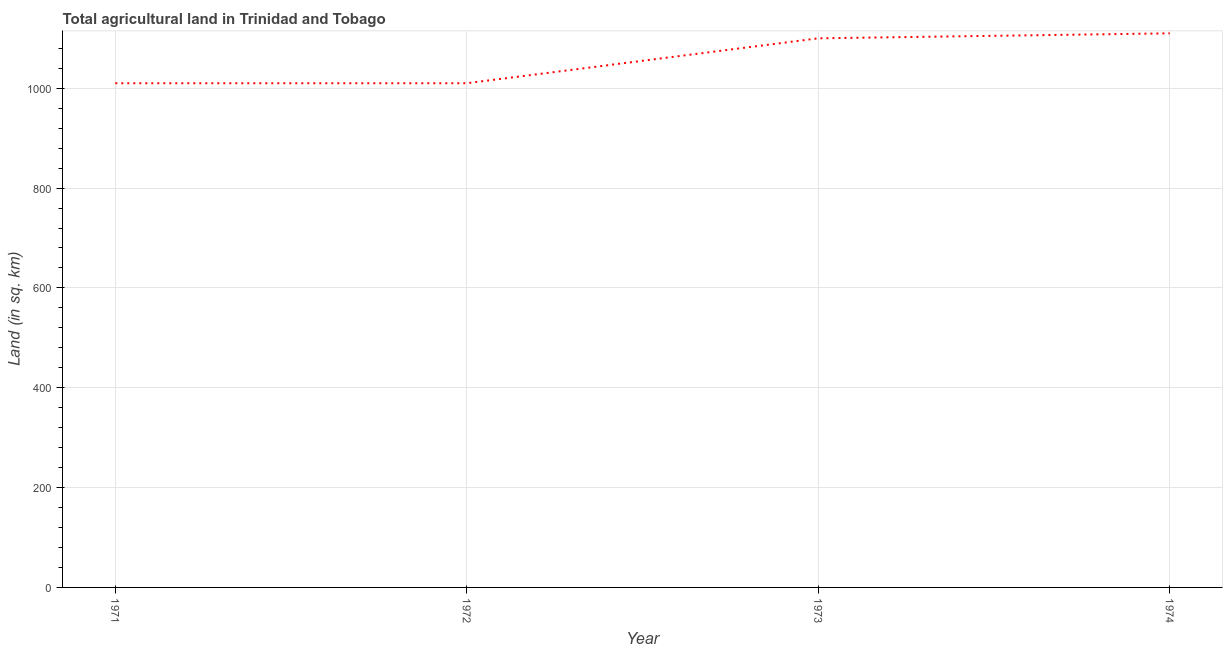What is the agricultural land in 1974?
Your answer should be very brief. 1110. Across all years, what is the maximum agricultural land?
Provide a succinct answer. 1110. Across all years, what is the minimum agricultural land?
Keep it short and to the point. 1010. In which year was the agricultural land maximum?
Offer a terse response. 1974. In which year was the agricultural land minimum?
Your answer should be compact. 1971. What is the sum of the agricultural land?
Make the answer very short. 4230. What is the difference between the agricultural land in 1972 and 1973?
Make the answer very short. -90. What is the average agricultural land per year?
Ensure brevity in your answer.  1057.5. What is the median agricultural land?
Make the answer very short. 1055. In how many years, is the agricultural land greater than 80 sq. km?
Make the answer very short. 4. What is the ratio of the agricultural land in 1972 to that in 1973?
Your answer should be very brief. 0.92. Is the difference between the agricultural land in 1971 and 1972 greater than the difference between any two years?
Ensure brevity in your answer.  No. What is the difference between the highest and the second highest agricultural land?
Provide a succinct answer. 10. Is the sum of the agricultural land in 1971 and 1972 greater than the maximum agricultural land across all years?
Make the answer very short. Yes. What is the difference between the highest and the lowest agricultural land?
Give a very brief answer. 100. In how many years, is the agricultural land greater than the average agricultural land taken over all years?
Make the answer very short. 2. Does the agricultural land monotonically increase over the years?
Ensure brevity in your answer.  No. How many years are there in the graph?
Provide a succinct answer. 4. Are the values on the major ticks of Y-axis written in scientific E-notation?
Offer a very short reply. No. What is the title of the graph?
Offer a very short reply. Total agricultural land in Trinidad and Tobago. What is the label or title of the Y-axis?
Offer a very short reply. Land (in sq. km). What is the Land (in sq. km) of 1971?
Provide a succinct answer. 1010. What is the Land (in sq. km) in 1972?
Keep it short and to the point. 1010. What is the Land (in sq. km) in 1973?
Offer a terse response. 1100. What is the Land (in sq. km) in 1974?
Keep it short and to the point. 1110. What is the difference between the Land (in sq. km) in 1971 and 1972?
Keep it short and to the point. 0. What is the difference between the Land (in sq. km) in 1971 and 1973?
Ensure brevity in your answer.  -90. What is the difference between the Land (in sq. km) in 1971 and 1974?
Keep it short and to the point. -100. What is the difference between the Land (in sq. km) in 1972 and 1973?
Provide a short and direct response. -90. What is the difference between the Land (in sq. km) in 1972 and 1974?
Provide a succinct answer. -100. What is the difference between the Land (in sq. km) in 1973 and 1974?
Your response must be concise. -10. What is the ratio of the Land (in sq. km) in 1971 to that in 1972?
Make the answer very short. 1. What is the ratio of the Land (in sq. km) in 1971 to that in 1973?
Ensure brevity in your answer.  0.92. What is the ratio of the Land (in sq. km) in 1971 to that in 1974?
Keep it short and to the point. 0.91. What is the ratio of the Land (in sq. km) in 1972 to that in 1973?
Offer a terse response. 0.92. What is the ratio of the Land (in sq. km) in 1972 to that in 1974?
Your response must be concise. 0.91. What is the ratio of the Land (in sq. km) in 1973 to that in 1974?
Provide a short and direct response. 0.99. 